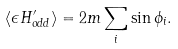<formula> <loc_0><loc_0><loc_500><loc_500>\langle \epsilon H ^ { \prime } _ { o d d } \rangle = 2 m \sum _ { i } \sin \phi _ { i } .</formula> 